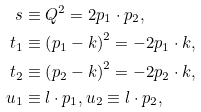Convert formula to latex. <formula><loc_0><loc_0><loc_500><loc_500>s & \equiv Q ^ { 2 } = 2 p _ { 1 } \cdot p _ { 2 } , \\ t _ { 1 } & \equiv \left ( p _ { 1 } - k \right ) ^ { 2 } = - 2 p _ { 1 } \cdot k , \\ t _ { 2 } & \equiv \left ( p _ { 2 } - k \right ) ^ { 2 } = - 2 p _ { 2 } \cdot k , \\ u _ { 1 } & \equiv l \cdot p _ { 1 } , u _ { 2 } \equiv l \cdot p _ { 2 } ,</formula> 